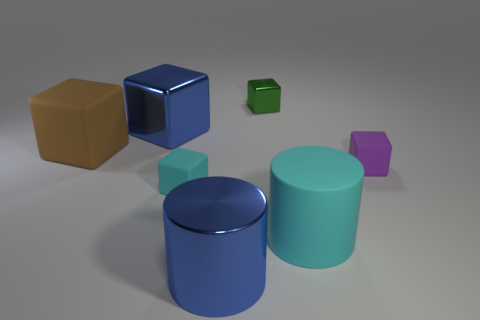Subtract all cyan blocks. How many blocks are left? 4 Subtract 2 cylinders. How many cylinders are left? 0 Add 3 blue shiny objects. How many objects exist? 10 Subtract all green blocks. How many blocks are left? 4 Subtract all blocks. How many objects are left? 2 Subtract 1 blue cubes. How many objects are left? 6 Subtract all blue cubes. Subtract all red cylinders. How many cubes are left? 4 Subtract all cyan cubes. Subtract all cyan matte cubes. How many objects are left? 5 Add 4 small cyan cubes. How many small cyan cubes are left? 5 Add 6 tiny matte blocks. How many tiny matte blocks exist? 8 